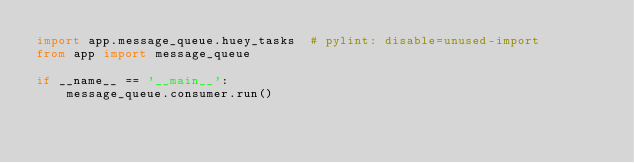Convert code to text. <code><loc_0><loc_0><loc_500><loc_500><_Python_>import app.message_queue.huey_tasks  # pylint: disable=unused-import
from app import message_queue

if __name__ == '__main__':
    message_queue.consumer.run()
</code> 